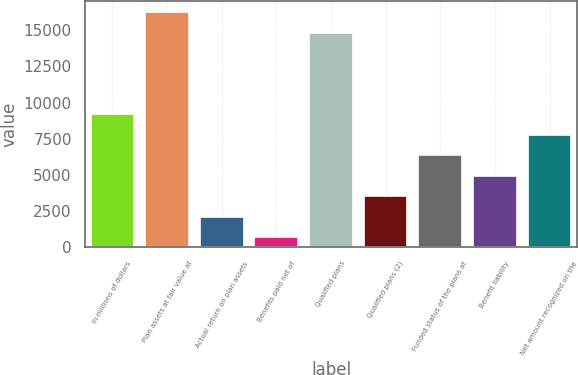Convert chart to OTSL. <chart><loc_0><loc_0><loc_500><loc_500><bar_chart><fcel>In millions of dollars<fcel>Plan assets at fair value at<fcel>Actual return on plan assets<fcel>Benefits paid net of<fcel>Qualified plans<fcel>Qualified plans (2)<fcel>Funded status of the plans at<fcel>Benefit liability<fcel>Net amount recognized on the<nl><fcel>9173<fcel>16233<fcel>2113<fcel>701<fcel>14821<fcel>3525<fcel>6349<fcel>4937<fcel>7761<nl></chart> 